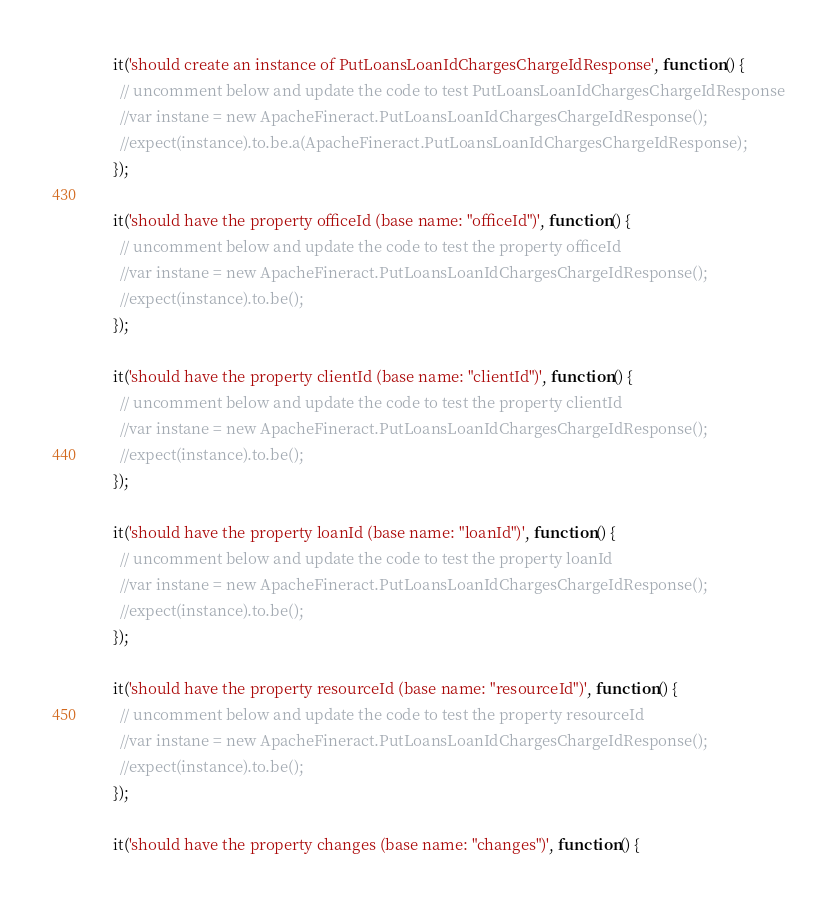Convert code to text. <code><loc_0><loc_0><loc_500><loc_500><_JavaScript_>    it('should create an instance of PutLoansLoanIdChargesChargeIdResponse', function() {
      // uncomment below and update the code to test PutLoansLoanIdChargesChargeIdResponse
      //var instane = new ApacheFineract.PutLoansLoanIdChargesChargeIdResponse();
      //expect(instance).to.be.a(ApacheFineract.PutLoansLoanIdChargesChargeIdResponse);
    });

    it('should have the property officeId (base name: "officeId")', function() {
      // uncomment below and update the code to test the property officeId
      //var instane = new ApacheFineract.PutLoansLoanIdChargesChargeIdResponse();
      //expect(instance).to.be();
    });

    it('should have the property clientId (base name: "clientId")', function() {
      // uncomment below and update the code to test the property clientId
      //var instane = new ApacheFineract.PutLoansLoanIdChargesChargeIdResponse();
      //expect(instance).to.be();
    });

    it('should have the property loanId (base name: "loanId")', function() {
      // uncomment below and update the code to test the property loanId
      //var instane = new ApacheFineract.PutLoansLoanIdChargesChargeIdResponse();
      //expect(instance).to.be();
    });

    it('should have the property resourceId (base name: "resourceId")', function() {
      // uncomment below and update the code to test the property resourceId
      //var instane = new ApacheFineract.PutLoansLoanIdChargesChargeIdResponse();
      //expect(instance).to.be();
    });

    it('should have the property changes (base name: "changes")', function() {</code> 